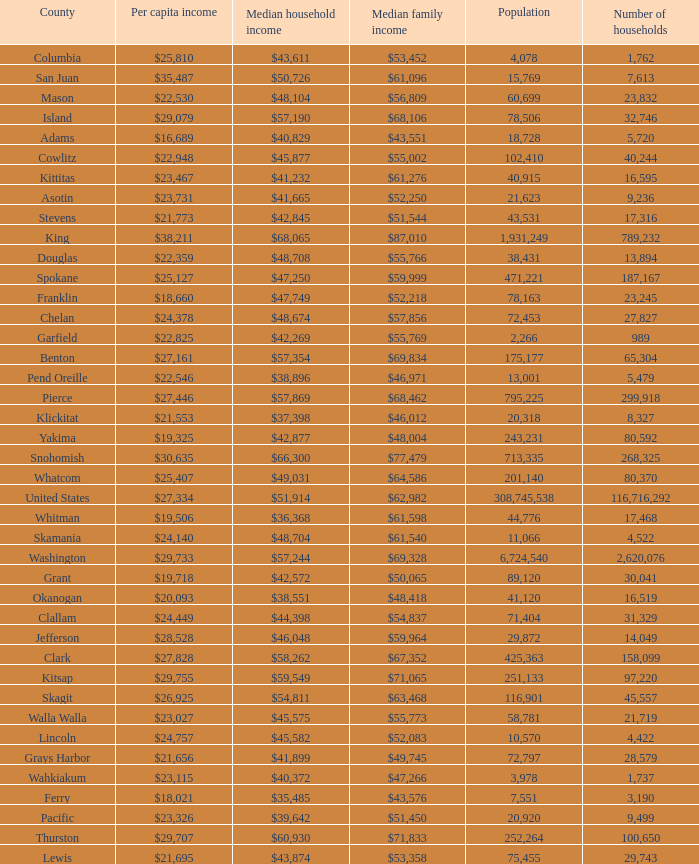How much is per capita income when median household income is $42,845? $21,773. 